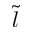<formula> <loc_0><loc_0><loc_500><loc_500>\tilde { l }</formula> 